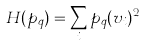Convert formula to latex. <formula><loc_0><loc_0><loc_500><loc_500>H ( p _ { q } ) = \sum _ { i } p _ { q } ( v _ { i } ) ^ { 2 }</formula> 